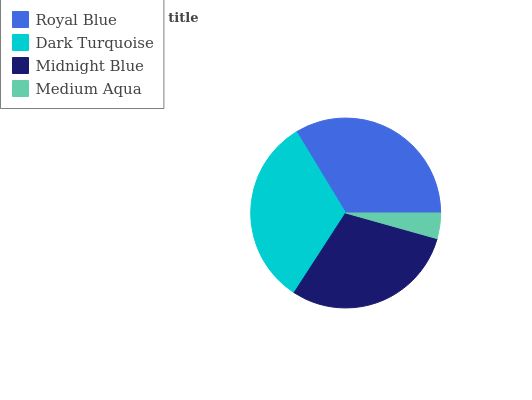Is Medium Aqua the minimum?
Answer yes or no. Yes. Is Royal Blue the maximum?
Answer yes or no. Yes. Is Dark Turquoise the minimum?
Answer yes or no. No. Is Dark Turquoise the maximum?
Answer yes or no. No. Is Royal Blue greater than Dark Turquoise?
Answer yes or no. Yes. Is Dark Turquoise less than Royal Blue?
Answer yes or no. Yes. Is Dark Turquoise greater than Royal Blue?
Answer yes or no. No. Is Royal Blue less than Dark Turquoise?
Answer yes or no. No. Is Dark Turquoise the high median?
Answer yes or no. Yes. Is Midnight Blue the low median?
Answer yes or no. Yes. Is Midnight Blue the high median?
Answer yes or no. No. Is Dark Turquoise the low median?
Answer yes or no. No. 